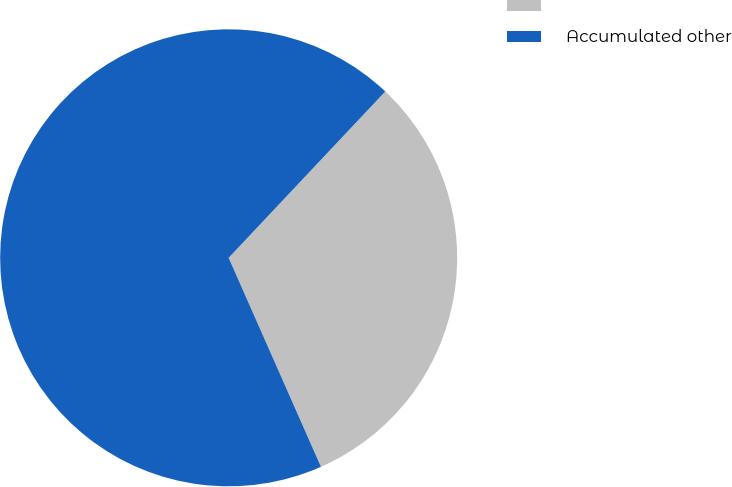<chart> <loc_0><loc_0><loc_500><loc_500><pie_chart><ecel><fcel>Accumulated other<nl><fcel>31.36%<fcel>68.64%<nl></chart> 